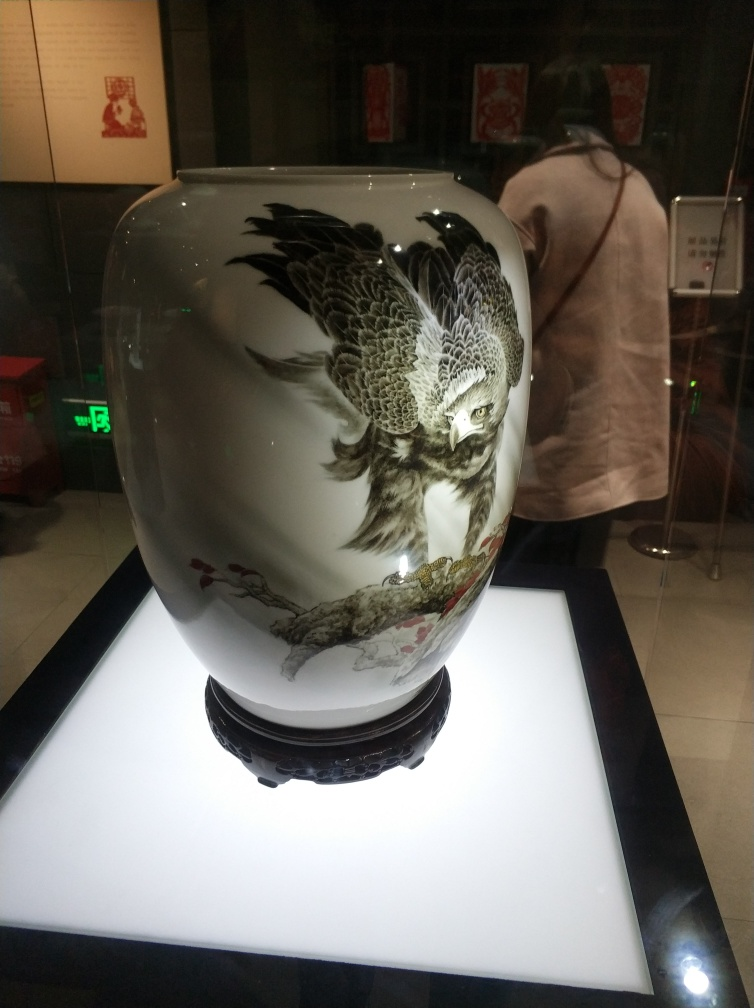Can you describe the artwork depicted on this vase? Certainly! The vase features an exquisite depiction of an owl in mid-flight. Its feathers are rendered in meticulous detail, showcasing various shades and textures that suggest a high level of craftsmanship. The background includes elements of flora, likely blossoms or leaves, which complement the central figure with their subtle coloring, enhancing the overall elegance of the piece. 